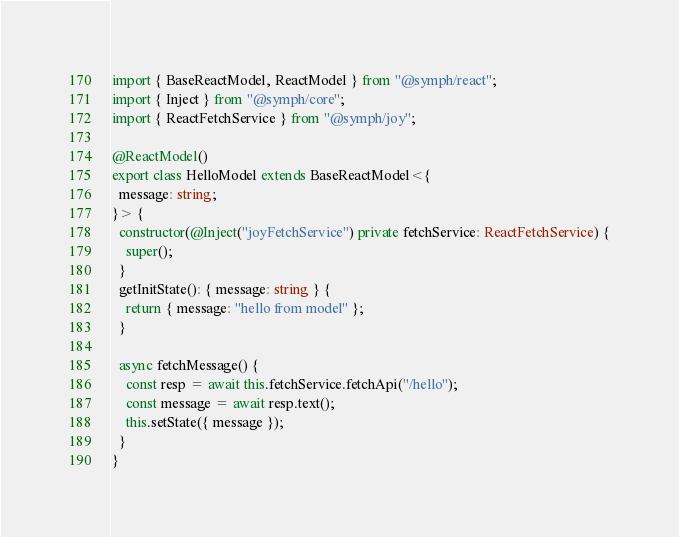<code> <loc_0><loc_0><loc_500><loc_500><_TypeScript_>import { BaseReactModel, ReactModel } from "@symph/react";
import { Inject } from "@symph/core";
import { ReactFetchService } from "@symph/joy";

@ReactModel()
export class HelloModel extends BaseReactModel<{
  message: string;
}> {
  constructor(@Inject("joyFetchService") private fetchService: ReactFetchService) {
    super();
  }
  getInitState(): { message: string } {
    return { message: "hello from model" };
  }

  async fetchMessage() {
    const resp = await this.fetchService.fetchApi("/hello");
    const message = await resp.text();
    this.setState({ message });
  }
}
</code> 